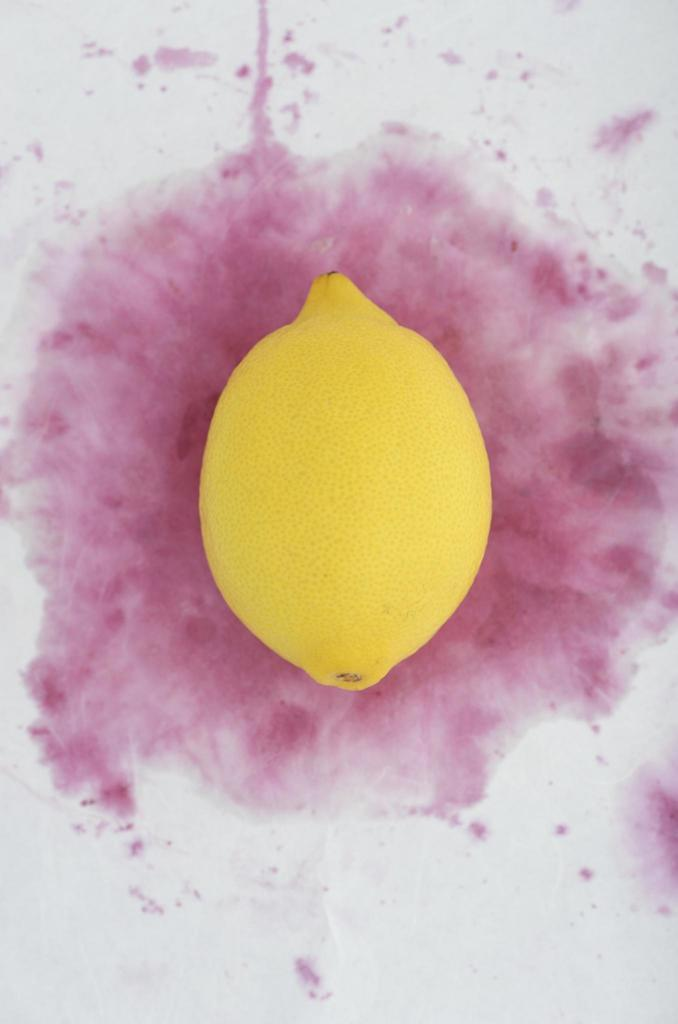What fruit is present in the image? There is a lemon in the image. What is the color of the lemon? The lemon is yellow in color. What can be seen in the background of the image? There is a white and pink colored surface in the background of the image. What type of trousers is the lemon wearing in the image? There are no trousers present in the image, as the lemon is a fruit and does not wear clothing. 